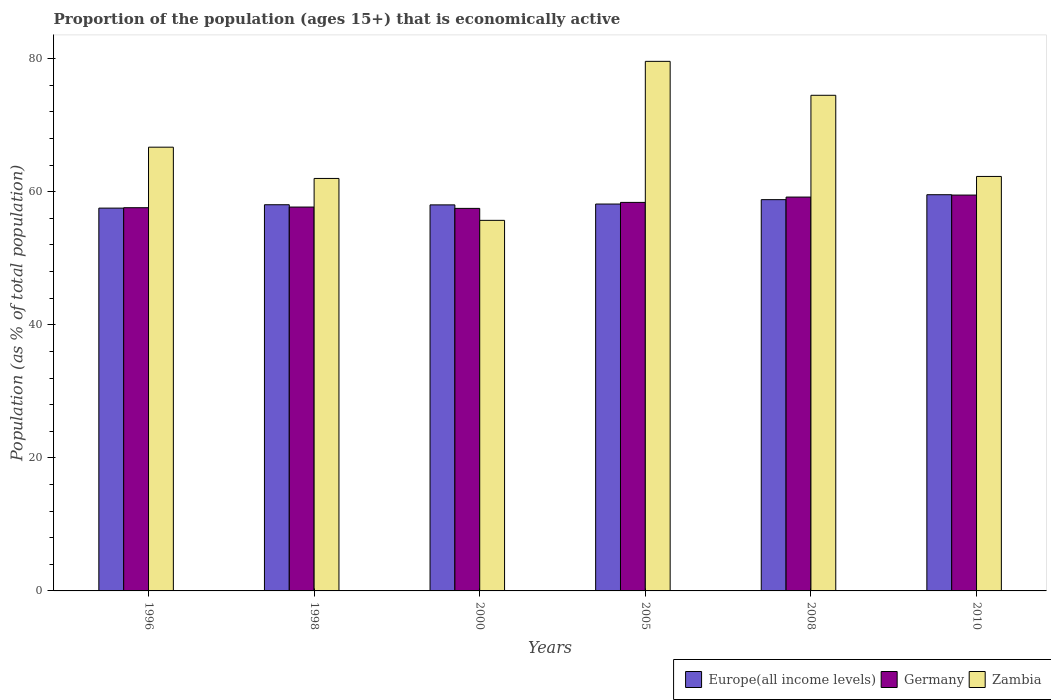Are the number of bars on each tick of the X-axis equal?
Your answer should be compact. Yes. How many bars are there on the 4th tick from the left?
Your response must be concise. 3. How many bars are there on the 1st tick from the right?
Offer a very short reply. 3. In how many cases, is the number of bars for a given year not equal to the number of legend labels?
Make the answer very short. 0. What is the proportion of the population that is economically active in Europe(all income levels) in 1996?
Make the answer very short. 57.54. Across all years, what is the maximum proportion of the population that is economically active in Europe(all income levels)?
Keep it short and to the point. 59.55. Across all years, what is the minimum proportion of the population that is economically active in Zambia?
Make the answer very short. 55.7. In which year was the proportion of the population that is economically active in Zambia maximum?
Offer a terse response. 2005. What is the total proportion of the population that is economically active in Europe(all income levels) in the graph?
Ensure brevity in your answer.  350.13. What is the difference between the proportion of the population that is economically active in Zambia in 2000 and that in 2010?
Provide a short and direct response. -6.6. What is the difference between the proportion of the population that is economically active in Germany in 2005 and the proportion of the population that is economically active in Europe(all income levels) in 1998?
Offer a very short reply. 0.35. What is the average proportion of the population that is economically active in Zambia per year?
Give a very brief answer. 66.8. In the year 2005, what is the difference between the proportion of the population that is economically active in Zambia and proportion of the population that is economically active in Europe(all income levels)?
Provide a short and direct response. 21.45. What is the ratio of the proportion of the population that is economically active in Zambia in 1998 to that in 2010?
Your answer should be very brief. 1. Is the proportion of the population that is economically active in Europe(all income levels) in 1996 less than that in 2005?
Your answer should be very brief. Yes. What is the difference between the highest and the second highest proportion of the population that is economically active in Europe(all income levels)?
Give a very brief answer. 0.74. In how many years, is the proportion of the population that is economically active in Europe(all income levels) greater than the average proportion of the population that is economically active in Europe(all income levels) taken over all years?
Keep it short and to the point. 2. Is the sum of the proportion of the population that is economically active in Zambia in 1998 and 2010 greater than the maximum proportion of the population that is economically active in Europe(all income levels) across all years?
Offer a terse response. Yes. What does the 3rd bar from the left in 2005 represents?
Give a very brief answer. Zambia. What does the 2nd bar from the right in 2000 represents?
Offer a terse response. Germany. How many bars are there?
Make the answer very short. 18. Are all the bars in the graph horizontal?
Offer a very short reply. No. How many years are there in the graph?
Ensure brevity in your answer.  6. What is the difference between two consecutive major ticks on the Y-axis?
Your answer should be compact. 20. Are the values on the major ticks of Y-axis written in scientific E-notation?
Offer a terse response. No. Where does the legend appear in the graph?
Give a very brief answer. Bottom right. How are the legend labels stacked?
Offer a terse response. Horizontal. What is the title of the graph?
Offer a very short reply. Proportion of the population (ages 15+) that is economically active. Does "St. Vincent and the Grenadines" appear as one of the legend labels in the graph?
Your answer should be very brief. No. What is the label or title of the X-axis?
Provide a short and direct response. Years. What is the label or title of the Y-axis?
Provide a succinct answer. Population (as % of total population). What is the Population (as % of total population) of Europe(all income levels) in 1996?
Provide a succinct answer. 57.54. What is the Population (as % of total population) in Germany in 1996?
Your answer should be compact. 57.6. What is the Population (as % of total population) of Zambia in 1996?
Offer a very short reply. 66.7. What is the Population (as % of total population) of Europe(all income levels) in 1998?
Your answer should be very brief. 58.05. What is the Population (as % of total population) in Germany in 1998?
Your response must be concise. 57.7. What is the Population (as % of total population) in Zambia in 1998?
Keep it short and to the point. 62. What is the Population (as % of total population) of Europe(all income levels) in 2000?
Offer a very short reply. 58.03. What is the Population (as % of total population) of Germany in 2000?
Offer a very short reply. 57.5. What is the Population (as % of total population) of Zambia in 2000?
Offer a terse response. 55.7. What is the Population (as % of total population) of Europe(all income levels) in 2005?
Make the answer very short. 58.15. What is the Population (as % of total population) of Germany in 2005?
Give a very brief answer. 58.4. What is the Population (as % of total population) in Zambia in 2005?
Ensure brevity in your answer.  79.6. What is the Population (as % of total population) in Europe(all income levels) in 2008?
Ensure brevity in your answer.  58.81. What is the Population (as % of total population) of Germany in 2008?
Give a very brief answer. 59.2. What is the Population (as % of total population) of Zambia in 2008?
Make the answer very short. 74.5. What is the Population (as % of total population) in Europe(all income levels) in 2010?
Ensure brevity in your answer.  59.55. What is the Population (as % of total population) in Germany in 2010?
Your answer should be compact. 59.5. What is the Population (as % of total population) in Zambia in 2010?
Ensure brevity in your answer.  62.3. Across all years, what is the maximum Population (as % of total population) in Europe(all income levels)?
Offer a terse response. 59.55. Across all years, what is the maximum Population (as % of total population) in Germany?
Provide a short and direct response. 59.5. Across all years, what is the maximum Population (as % of total population) in Zambia?
Your answer should be compact. 79.6. Across all years, what is the minimum Population (as % of total population) in Europe(all income levels)?
Provide a succinct answer. 57.54. Across all years, what is the minimum Population (as % of total population) of Germany?
Your response must be concise. 57.5. Across all years, what is the minimum Population (as % of total population) in Zambia?
Keep it short and to the point. 55.7. What is the total Population (as % of total population) of Europe(all income levels) in the graph?
Your answer should be very brief. 350.13. What is the total Population (as % of total population) of Germany in the graph?
Your answer should be compact. 349.9. What is the total Population (as % of total population) in Zambia in the graph?
Offer a very short reply. 400.8. What is the difference between the Population (as % of total population) of Europe(all income levels) in 1996 and that in 1998?
Your response must be concise. -0.51. What is the difference between the Population (as % of total population) in Zambia in 1996 and that in 1998?
Your answer should be compact. 4.7. What is the difference between the Population (as % of total population) of Europe(all income levels) in 1996 and that in 2000?
Provide a short and direct response. -0.49. What is the difference between the Population (as % of total population) in Germany in 1996 and that in 2000?
Your answer should be very brief. 0.1. What is the difference between the Population (as % of total population) in Europe(all income levels) in 1996 and that in 2005?
Your answer should be very brief. -0.61. What is the difference between the Population (as % of total population) of Zambia in 1996 and that in 2005?
Provide a short and direct response. -12.9. What is the difference between the Population (as % of total population) in Europe(all income levels) in 1996 and that in 2008?
Your response must be concise. -1.27. What is the difference between the Population (as % of total population) in Germany in 1996 and that in 2008?
Offer a very short reply. -1.6. What is the difference between the Population (as % of total population) of Europe(all income levels) in 1996 and that in 2010?
Keep it short and to the point. -2.02. What is the difference between the Population (as % of total population) in Europe(all income levels) in 1998 and that in 2000?
Your answer should be compact. 0.02. What is the difference between the Population (as % of total population) in Zambia in 1998 and that in 2000?
Keep it short and to the point. 6.3. What is the difference between the Population (as % of total population) of Europe(all income levels) in 1998 and that in 2005?
Ensure brevity in your answer.  -0.11. What is the difference between the Population (as % of total population) in Germany in 1998 and that in 2005?
Offer a terse response. -0.7. What is the difference between the Population (as % of total population) of Zambia in 1998 and that in 2005?
Provide a short and direct response. -17.6. What is the difference between the Population (as % of total population) of Europe(all income levels) in 1998 and that in 2008?
Ensure brevity in your answer.  -0.77. What is the difference between the Population (as % of total population) of Germany in 1998 and that in 2008?
Offer a very short reply. -1.5. What is the difference between the Population (as % of total population) of Europe(all income levels) in 1998 and that in 2010?
Keep it short and to the point. -1.51. What is the difference between the Population (as % of total population) in Europe(all income levels) in 2000 and that in 2005?
Your response must be concise. -0.13. What is the difference between the Population (as % of total population) in Zambia in 2000 and that in 2005?
Provide a succinct answer. -23.9. What is the difference between the Population (as % of total population) of Europe(all income levels) in 2000 and that in 2008?
Provide a short and direct response. -0.79. What is the difference between the Population (as % of total population) of Germany in 2000 and that in 2008?
Give a very brief answer. -1.7. What is the difference between the Population (as % of total population) in Zambia in 2000 and that in 2008?
Your response must be concise. -18.8. What is the difference between the Population (as % of total population) in Europe(all income levels) in 2000 and that in 2010?
Offer a terse response. -1.53. What is the difference between the Population (as % of total population) of Germany in 2000 and that in 2010?
Offer a terse response. -2. What is the difference between the Population (as % of total population) of Europe(all income levels) in 2005 and that in 2008?
Provide a short and direct response. -0.66. What is the difference between the Population (as % of total population) in Germany in 2005 and that in 2008?
Provide a short and direct response. -0.8. What is the difference between the Population (as % of total population) of Zambia in 2005 and that in 2008?
Ensure brevity in your answer.  5.1. What is the difference between the Population (as % of total population) of Europe(all income levels) in 2005 and that in 2010?
Your response must be concise. -1.4. What is the difference between the Population (as % of total population) of Zambia in 2005 and that in 2010?
Provide a short and direct response. 17.3. What is the difference between the Population (as % of total population) in Europe(all income levels) in 2008 and that in 2010?
Ensure brevity in your answer.  -0.74. What is the difference between the Population (as % of total population) in Germany in 2008 and that in 2010?
Your response must be concise. -0.3. What is the difference between the Population (as % of total population) of Europe(all income levels) in 1996 and the Population (as % of total population) of Germany in 1998?
Keep it short and to the point. -0.16. What is the difference between the Population (as % of total population) of Europe(all income levels) in 1996 and the Population (as % of total population) of Zambia in 1998?
Offer a very short reply. -4.46. What is the difference between the Population (as % of total population) of Europe(all income levels) in 1996 and the Population (as % of total population) of Germany in 2000?
Give a very brief answer. 0.04. What is the difference between the Population (as % of total population) of Europe(all income levels) in 1996 and the Population (as % of total population) of Zambia in 2000?
Provide a succinct answer. 1.84. What is the difference between the Population (as % of total population) in Europe(all income levels) in 1996 and the Population (as % of total population) in Germany in 2005?
Your answer should be very brief. -0.86. What is the difference between the Population (as % of total population) of Europe(all income levels) in 1996 and the Population (as % of total population) of Zambia in 2005?
Your answer should be compact. -22.06. What is the difference between the Population (as % of total population) in Germany in 1996 and the Population (as % of total population) in Zambia in 2005?
Your answer should be compact. -22. What is the difference between the Population (as % of total population) in Europe(all income levels) in 1996 and the Population (as % of total population) in Germany in 2008?
Give a very brief answer. -1.66. What is the difference between the Population (as % of total population) in Europe(all income levels) in 1996 and the Population (as % of total population) in Zambia in 2008?
Offer a terse response. -16.96. What is the difference between the Population (as % of total population) of Germany in 1996 and the Population (as % of total population) of Zambia in 2008?
Make the answer very short. -16.9. What is the difference between the Population (as % of total population) of Europe(all income levels) in 1996 and the Population (as % of total population) of Germany in 2010?
Keep it short and to the point. -1.96. What is the difference between the Population (as % of total population) in Europe(all income levels) in 1996 and the Population (as % of total population) in Zambia in 2010?
Your response must be concise. -4.76. What is the difference between the Population (as % of total population) in Germany in 1996 and the Population (as % of total population) in Zambia in 2010?
Provide a succinct answer. -4.7. What is the difference between the Population (as % of total population) in Europe(all income levels) in 1998 and the Population (as % of total population) in Germany in 2000?
Offer a terse response. 0.55. What is the difference between the Population (as % of total population) of Europe(all income levels) in 1998 and the Population (as % of total population) of Zambia in 2000?
Make the answer very short. 2.35. What is the difference between the Population (as % of total population) in Germany in 1998 and the Population (as % of total population) in Zambia in 2000?
Offer a terse response. 2. What is the difference between the Population (as % of total population) of Europe(all income levels) in 1998 and the Population (as % of total population) of Germany in 2005?
Keep it short and to the point. -0.35. What is the difference between the Population (as % of total population) of Europe(all income levels) in 1998 and the Population (as % of total population) of Zambia in 2005?
Offer a very short reply. -21.55. What is the difference between the Population (as % of total population) in Germany in 1998 and the Population (as % of total population) in Zambia in 2005?
Offer a very short reply. -21.9. What is the difference between the Population (as % of total population) of Europe(all income levels) in 1998 and the Population (as % of total population) of Germany in 2008?
Offer a terse response. -1.15. What is the difference between the Population (as % of total population) in Europe(all income levels) in 1998 and the Population (as % of total population) in Zambia in 2008?
Your answer should be compact. -16.45. What is the difference between the Population (as % of total population) in Germany in 1998 and the Population (as % of total population) in Zambia in 2008?
Ensure brevity in your answer.  -16.8. What is the difference between the Population (as % of total population) of Europe(all income levels) in 1998 and the Population (as % of total population) of Germany in 2010?
Your response must be concise. -1.45. What is the difference between the Population (as % of total population) in Europe(all income levels) in 1998 and the Population (as % of total population) in Zambia in 2010?
Keep it short and to the point. -4.25. What is the difference between the Population (as % of total population) of Germany in 1998 and the Population (as % of total population) of Zambia in 2010?
Offer a very short reply. -4.6. What is the difference between the Population (as % of total population) of Europe(all income levels) in 2000 and the Population (as % of total population) of Germany in 2005?
Your answer should be very brief. -0.37. What is the difference between the Population (as % of total population) of Europe(all income levels) in 2000 and the Population (as % of total population) of Zambia in 2005?
Keep it short and to the point. -21.57. What is the difference between the Population (as % of total population) in Germany in 2000 and the Population (as % of total population) in Zambia in 2005?
Your answer should be compact. -22.1. What is the difference between the Population (as % of total population) of Europe(all income levels) in 2000 and the Population (as % of total population) of Germany in 2008?
Provide a short and direct response. -1.17. What is the difference between the Population (as % of total population) of Europe(all income levels) in 2000 and the Population (as % of total population) of Zambia in 2008?
Your answer should be compact. -16.47. What is the difference between the Population (as % of total population) of Germany in 2000 and the Population (as % of total population) of Zambia in 2008?
Your response must be concise. -17. What is the difference between the Population (as % of total population) in Europe(all income levels) in 2000 and the Population (as % of total population) in Germany in 2010?
Keep it short and to the point. -1.47. What is the difference between the Population (as % of total population) in Europe(all income levels) in 2000 and the Population (as % of total population) in Zambia in 2010?
Ensure brevity in your answer.  -4.27. What is the difference between the Population (as % of total population) of Germany in 2000 and the Population (as % of total population) of Zambia in 2010?
Your answer should be very brief. -4.8. What is the difference between the Population (as % of total population) of Europe(all income levels) in 2005 and the Population (as % of total population) of Germany in 2008?
Your response must be concise. -1.05. What is the difference between the Population (as % of total population) in Europe(all income levels) in 2005 and the Population (as % of total population) in Zambia in 2008?
Your response must be concise. -16.35. What is the difference between the Population (as % of total population) of Germany in 2005 and the Population (as % of total population) of Zambia in 2008?
Keep it short and to the point. -16.1. What is the difference between the Population (as % of total population) of Europe(all income levels) in 2005 and the Population (as % of total population) of Germany in 2010?
Provide a succinct answer. -1.35. What is the difference between the Population (as % of total population) in Europe(all income levels) in 2005 and the Population (as % of total population) in Zambia in 2010?
Make the answer very short. -4.15. What is the difference between the Population (as % of total population) of Europe(all income levels) in 2008 and the Population (as % of total population) of Germany in 2010?
Keep it short and to the point. -0.69. What is the difference between the Population (as % of total population) of Europe(all income levels) in 2008 and the Population (as % of total population) of Zambia in 2010?
Your answer should be compact. -3.49. What is the average Population (as % of total population) in Europe(all income levels) per year?
Provide a short and direct response. 58.36. What is the average Population (as % of total population) in Germany per year?
Make the answer very short. 58.32. What is the average Population (as % of total population) of Zambia per year?
Give a very brief answer. 66.8. In the year 1996, what is the difference between the Population (as % of total population) of Europe(all income levels) and Population (as % of total population) of Germany?
Provide a short and direct response. -0.06. In the year 1996, what is the difference between the Population (as % of total population) in Europe(all income levels) and Population (as % of total population) in Zambia?
Provide a short and direct response. -9.16. In the year 1998, what is the difference between the Population (as % of total population) of Europe(all income levels) and Population (as % of total population) of Germany?
Provide a short and direct response. 0.35. In the year 1998, what is the difference between the Population (as % of total population) of Europe(all income levels) and Population (as % of total population) of Zambia?
Provide a succinct answer. -3.95. In the year 1998, what is the difference between the Population (as % of total population) in Germany and Population (as % of total population) in Zambia?
Your answer should be compact. -4.3. In the year 2000, what is the difference between the Population (as % of total population) of Europe(all income levels) and Population (as % of total population) of Germany?
Offer a very short reply. 0.53. In the year 2000, what is the difference between the Population (as % of total population) of Europe(all income levels) and Population (as % of total population) of Zambia?
Keep it short and to the point. 2.33. In the year 2000, what is the difference between the Population (as % of total population) of Germany and Population (as % of total population) of Zambia?
Offer a terse response. 1.8. In the year 2005, what is the difference between the Population (as % of total population) of Europe(all income levels) and Population (as % of total population) of Germany?
Give a very brief answer. -0.25. In the year 2005, what is the difference between the Population (as % of total population) in Europe(all income levels) and Population (as % of total population) in Zambia?
Provide a succinct answer. -21.45. In the year 2005, what is the difference between the Population (as % of total population) in Germany and Population (as % of total population) in Zambia?
Provide a succinct answer. -21.2. In the year 2008, what is the difference between the Population (as % of total population) in Europe(all income levels) and Population (as % of total population) in Germany?
Your answer should be compact. -0.39. In the year 2008, what is the difference between the Population (as % of total population) of Europe(all income levels) and Population (as % of total population) of Zambia?
Give a very brief answer. -15.69. In the year 2008, what is the difference between the Population (as % of total population) in Germany and Population (as % of total population) in Zambia?
Provide a short and direct response. -15.3. In the year 2010, what is the difference between the Population (as % of total population) of Europe(all income levels) and Population (as % of total population) of Germany?
Provide a short and direct response. 0.05. In the year 2010, what is the difference between the Population (as % of total population) of Europe(all income levels) and Population (as % of total population) of Zambia?
Provide a short and direct response. -2.75. In the year 2010, what is the difference between the Population (as % of total population) of Germany and Population (as % of total population) of Zambia?
Your response must be concise. -2.8. What is the ratio of the Population (as % of total population) of Zambia in 1996 to that in 1998?
Give a very brief answer. 1.08. What is the ratio of the Population (as % of total population) of Zambia in 1996 to that in 2000?
Your answer should be very brief. 1.2. What is the ratio of the Population (as % of total population) of Germany in 1996 to that in 2005?
Your answer should be compact. 0.99. What is the ratio of the Population (as % of total population) in Zambia in 1996 to that in 2005?
Offer a very short reply. 0.84. What is the ratio of the Population (as % of total population) in Europe(all income levels) in 1996 to that in 2008?
Offer a terse response. 0.98. What is the ratio of the Population (as % of total population) of Zambia in 1996 to that in 2008?
Ensure brevity in your answer.  0.9. What is the ratio of the Population (as % of total population) in Europe(all income levels) in 1996 to that in 2010?
Your answer should be very brief. 0.97. What is the ratio of the Population (as % of total population) of Germany in 1996 to that in 2010?
Your answer should be compact. 0.97. What is the ratio of the Population (as % of total population) of Zambia in 1996 to that in 2010?
Provide a short and direct response. 1.07. What is the ratio of the Population (as % of total population) in Europe(all income levels) in 1998 to that in 2000?
Give a very brief answer. 1. What is the ratio of the Population (as % of total population) in Germany in 1998 to that in 2000?
Make the answer very short. 1. What is the ratio of the Population (as % of total population) in Zambia in 1998 to that in 2000?
Make the answer very short. 1.11. What is the ratio of the Population (as % of total population) in Europe(all income levels) in 1998 to that in 2005?
Ensure brevity in your answer.  1. What is the ratio of the Population (as % of total population) in Germany in 1998 to that in 2005?
Your answer should be compact. 0.99. What is the ratio of the Population (as % of total population) of Zambia in 1998 to that in 2005?
Give a very brief answer. 0.78. What is the ratio of the Population (as % of total population) of Germany in 1998 to that in 2008?
Provide a succinct answer. 0.97. What is the ratio of the Population (as % of total population) in Zambia in 1998 to that in 2008?
Your answer should be very brief. 0.83. What is the ratio of the Population (as % of total population) in Europe(all income levels) in 1998 to that in 2010?
Offer a terse response. 0.97. What is the ratio of the Population (as % of total population) in Germany in 1998 to that in 2010?
Keep it short and to the point. 0.97. What is the ratio of the Population (as % of total population) of Zambia in 1998 to that in 2010?
Your answer should be compact. 1. What is the ratio of the Population (as % of total population) of Europe(all income levels) in 2000 to that in 2005?
Give a very brief answer. 1. What is the ratio of the Population (as % of total population) in Germany in 2000 to that in 2005?
Provide a short and direct response. 0.98. What is the ratio of the Population (as % of total population) of Zambia in 2000 to that in 2005?
Give a very brief answer. 0.7. What is the ratio of the Population (as % of total population) in Europe(all income levels) in 2000 to that in 2008?
Give a very brief answer. 0.99. What is the ratio of the Population (as % of total population) of Germany in 2000 to that in 2008?
Your answer should be very brief. 0.97. What is the ratio of the Population (as % of total population) of Zambia in 2000 to that in 2008?
Provide a short and direct response. 0.75. What is the ratio of the Population (as % of total population) in Europe(all income levels) in 2000 to that in 2010?
Offer a terse response. 0.97. What is the ratio of the Population (as % of total population) in Germany in 2000 to that in 2010?
Ensure brevity in your answer.  0.97. What is the ratio of the Population (as % of total population) in Zambia in 2000 to that in 2010?
Your response must be concise. 0.89. What is the ratio of the Population (as % of total population) in Germany in 2005 to that in 2008?
Ensure brevity in your answer.  0.99. What is the ratio of the Population (as % of total population) in Zambia in 2005 to that in 2008?
Provide a succinct answer. 1.07. What is the ratio of the Population (as % of total population) of Europe(all income levels) in 2005 to that in 2010?
Offer a very short reply. 0.98. What is the ratio of the Population (as % of total population) of Germany in 2005 to that in 2010?
Make the answer very short. 0.98. What is the ratio of the Population (as % of total population) in Zambia in 2005 to that in 2010?
Make the answer very short. 1.28. What is the ratio of the Population (as % of total population) in Europe(all income levels) in 2008 to that in 2010?
Make the answer very short. 0.99. What is the ratio of the Population (as % of total population) of Germany in 2008 to that in 2010?
Offer a very short reply. 0.99. What is the ratio of the Population (as % of total population) of Zambia in 2008 to that in 2010?
Your answer should be compact. 1.2. What is the difference between the highest and the second highest Population (as % of total population) in Europe(all income levels)?
Your response must be concise. 0.74. What is the difference between the highest and the second highest Population (as % of total population) in Germany?
Offer a very short reply. 0.3. What is the difference between the highest and the second highest Population (as % of total population) of Zambia?
Give a very brief answer. 5.1. What is the difference between the highest and the lowest Population (as % of total population) of Europe(all income levels)?
Ensure brevity in your answer.  2.02. What is the difference between the highest and the lowest Population (as % of total population) in Germany?
Keep it short and to the point. 2. What is the difference between the highest and the lowest Population (as % of total population) of Zambia?
Offer a terse response. 23.9. 